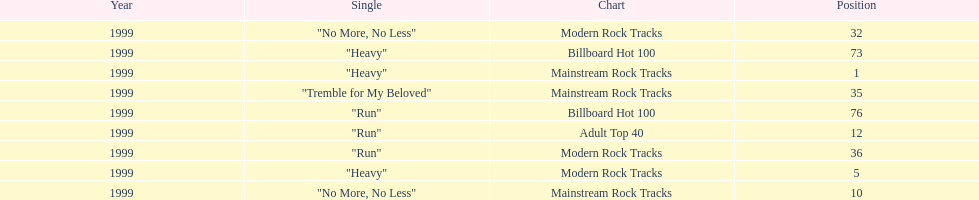How many singles from "dosage" appeared on the modern rock tracks charts? 3. Could you help me parse every detail presented in this table? {'header': ['Year', 'Single', 'Chart', 'Position'], 'rows': [['1999', '"No More, No Less"', 'Modern Rock Tracks', '32'], ['1999', '"Heavy"', 'Billboard Hot 100', '73'], ['1999', '"Heavy"', 'Mainstream Rock Tracks', '1'], ['1999', '"Tremble for My Beloved"', 'Mainstream Rock Tracks', '35'], ['1999', '"Run"', 'Billboard Hot 100', '76'], ['1999', '"Run"', 'Adult Top 40', '12'], ['1999', '"Run"', 'Modern Rock Tracks', '36'], ['1999', '"Heavy"', 'Modern Rock Tracks', '5'], ['1999', '"No More, No Less"', 'Mainstream Rock Tracks', '10']]} 